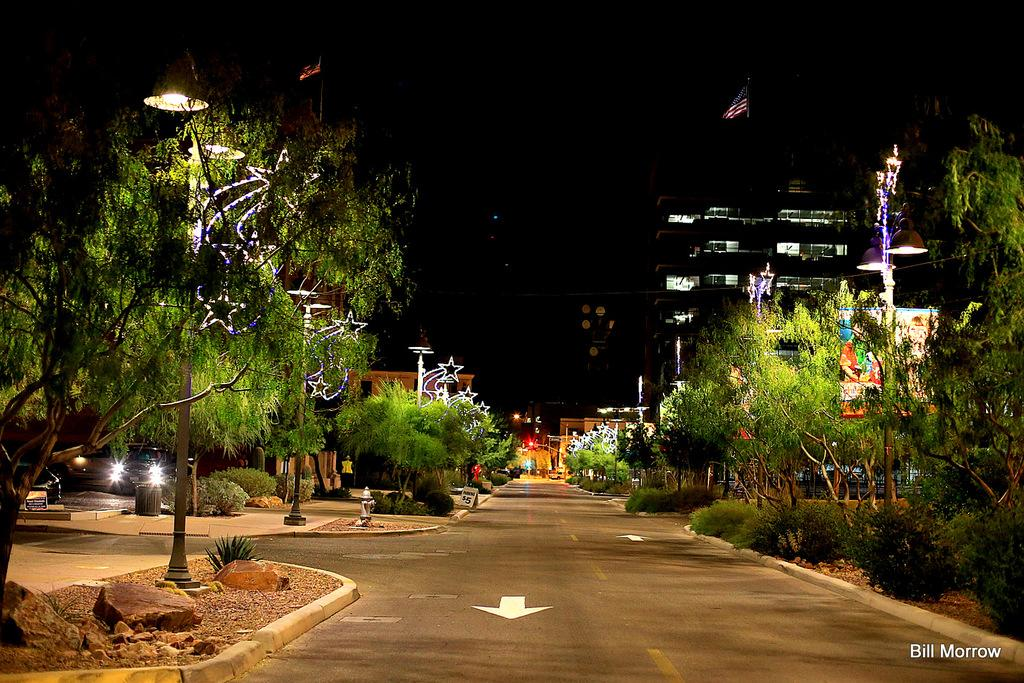What type of natural elements can be seen in the image? There is a group of trees in the image. What man-made structures are present in the image? There are poles, a building, and a flag in the image. What vehicles can be seen in the image? Several cars are parked on the ground in the image. Where is the bottle located in the image? There is no bottle present in the image. What type of engine is powering the flag in the image? The flag is not powered by an engine; it is likely attached to a pole or building. 